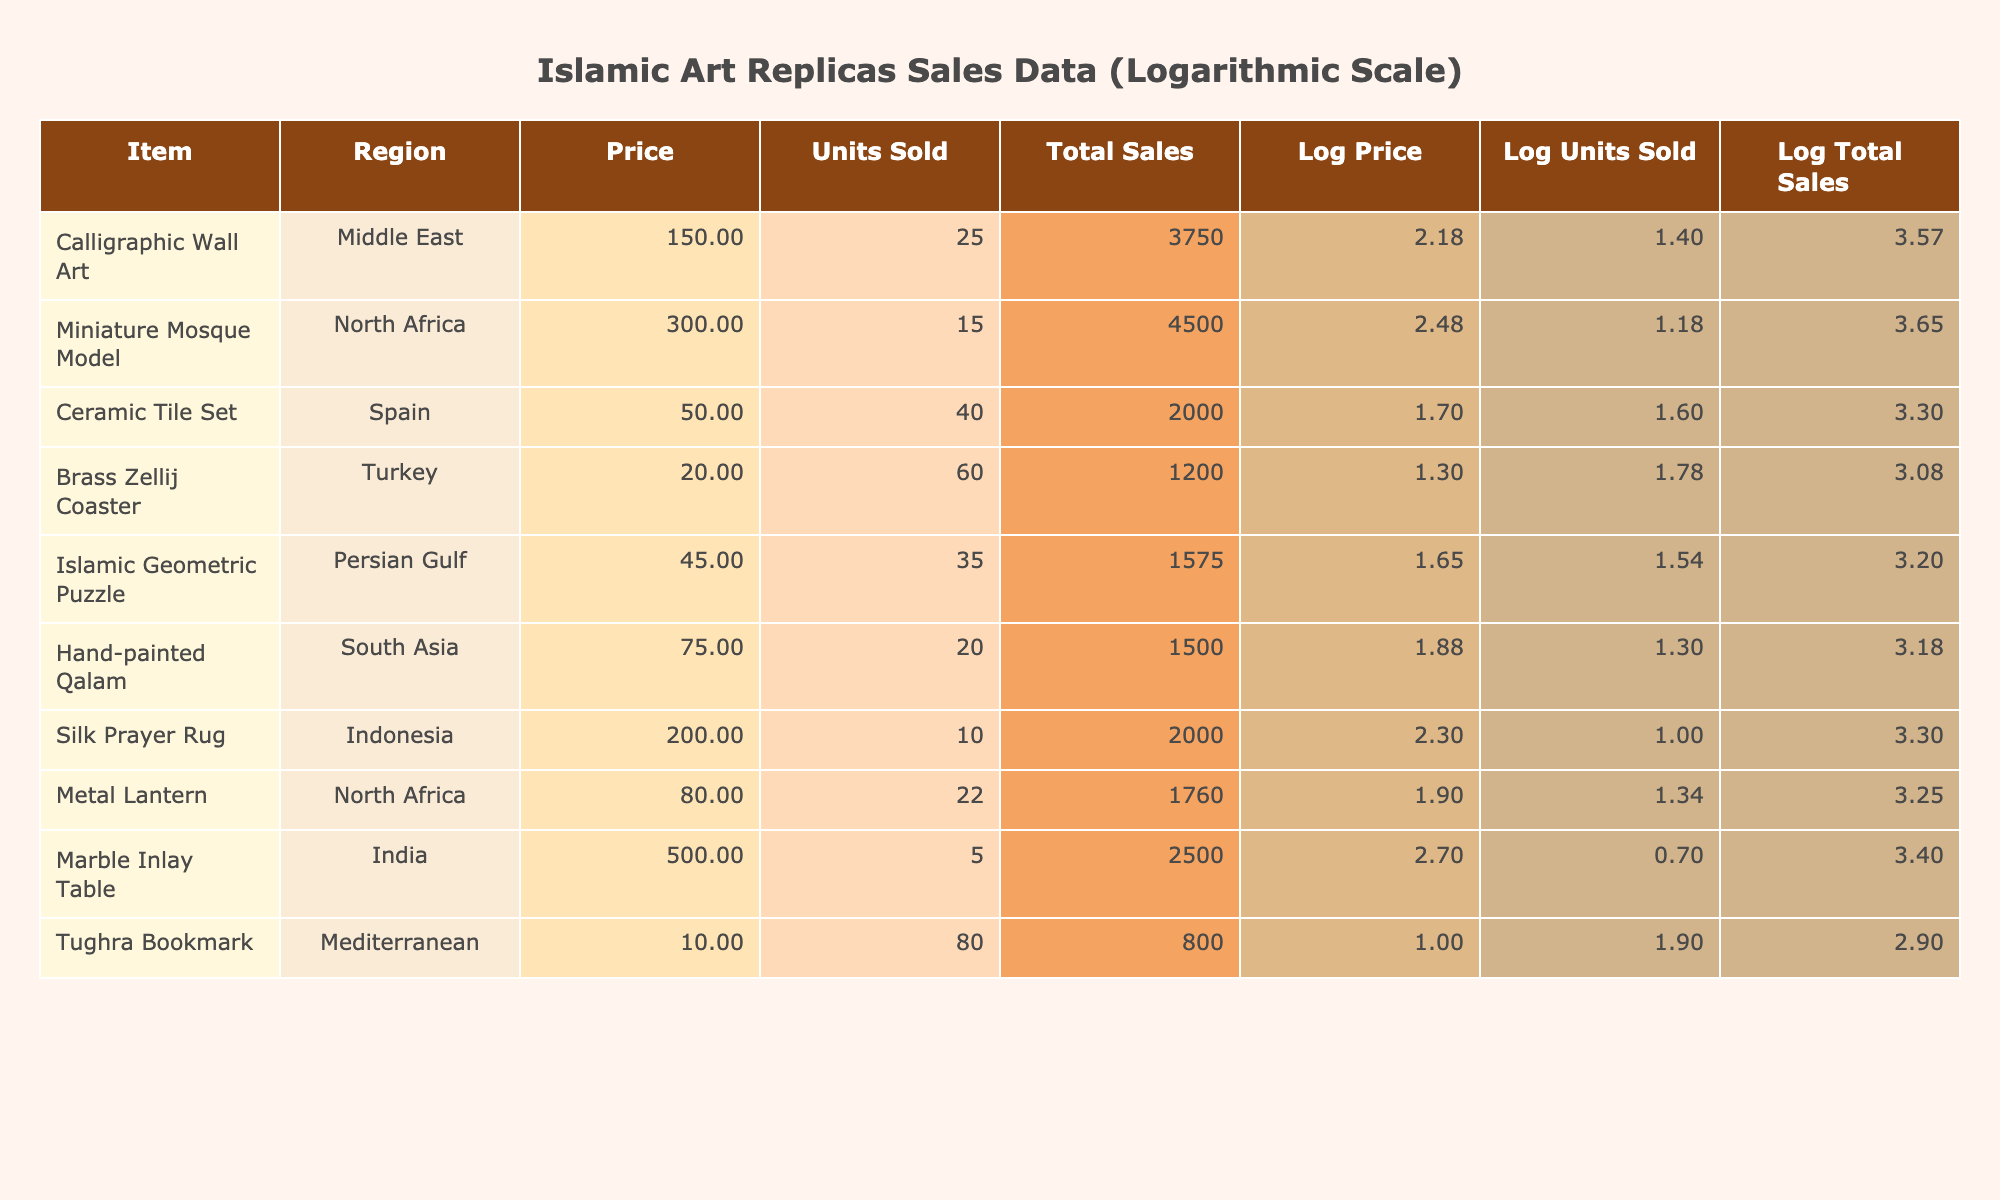What is the selling price of the Marble Inlay Table? The selling price of the Marble Inlay Table is listed in the Price column of the table. Looking under the 'Price' column for the 'Marble Inlay Table', the value is 500.
Answer: 500 Which item from North Africa had the highest total sales? To find this, we look at the 'Total Sales' column and identify items from the North Africa region. The items are Miniature Mosque Model with a Total Sales of 4500, and Metal Lantern with 1760. The Miniature Mosque Model is the highest.
Answer: Miniature Mosque Model What is the total number of units sold across all items? To calculate the total units sold, we sum up the 'Units Sold' column values: 25 + 15 + 40 + 60 + 35 + 20 + 10 + 22 + 5 + 80 = 322.
Answer: 322 Is the total sales amount for the Islamic Geometric Puzzle greater than that of the Calligraphic Wall Art? The total sales for the Islamic Geometric Puzzle is 1575 while for the Calligraphic Wall Art it is 3750. Since 1575 is less than 3750, the statement is false.
Answer: No What is the average price of all items listed in the table? The average price is calculated by summing all the prices: 150 + 300 + 50 + 20 + 45 + 75 + 200 + 80 + 500 + 10 = 1430. Dividing this sum by the number of items (10), we get 1430 / 10 = 143.
Answer: 143 Which region has the lowest average units sold per item? To find the region with the lowest average units sold, we first calculate the average units sold for each region: Middle East (25), North Africa (15 + 22) / 2 = 18.5, Persian Gulf (35), South Asia (20), Indonesia (10), Turkey (60), India (5), Mediterranean (80). The lowest average is for India with 5.
Answer: India How many total sales do the items from the South Asia region generate? The total sales for South Asia is found by checking the Total Sales column for the Hand-painted Qalam, which is 1500. Since it is the only item from this region, it is the total.
Answer: 1500 Are there more items sold in the Mediterranean region than in the Middle East? In the Mediterranean, there is one item (Tughra Bookmark) sold in 80 units, while in the Middle East, there is one item (Calligraphic Wall Art) sold in 25 units. Since 80 is greater than 25, the statement is true.
Answer: Yes What percentage of the total sales comes from the Calligraphic Wall Art? Total sales are calculated as 3750 (Calligraphic Wall Art) + 4500 + 2000 + 1200 + 1575 + 1500 + 2000 + 1760 + 2500 + 800 = 19585. The percentage from Calligraphic Wall Art is (3750 / 19585) * 100 = 19.1%.
Answer: 19.1% 